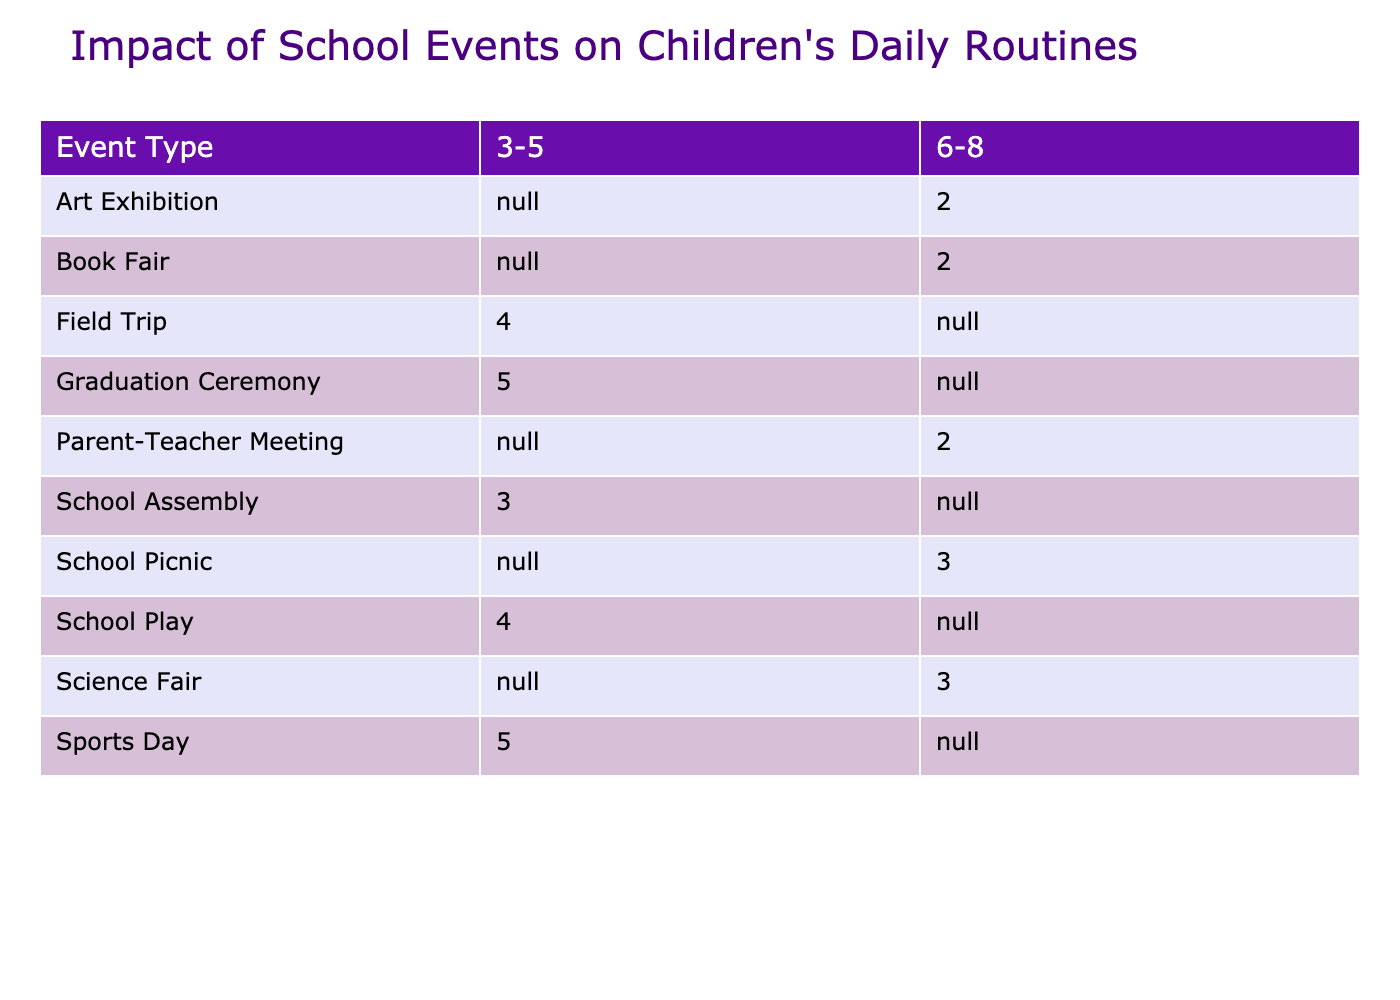What is the disruption level of Sports Day for the 3-5 age group? From the table, under the event "Sports Day" and in the column for the 3-5 age group, the disruption level is listed as 5.
Answer: 5 Which event has the highest average disruption level for children aged 3-5? By looking at the disruption levels for the 3-5 age group: School Play (4), Sports Day (5), School Assembly (3), Graduation Ceremony (5), and Field Trip (4), the highest average disruption levels are shared by Sports Day and Graduation Ceremony, both at 5.
Answer: Sports Day and Graduation Ceremony What is the average disruption level for the 6-8 age group? To find the average disruption level for the 6-8 age group, we will take the disruption levels: Picnic (3), Parent-Teacher Meeting (2), Art Exhibition (2), Science Fair (3), and Book Fair (2). Summing these gives us 3 + 2 + 2 + 3 + 2 = 12. There are 5 events, so the average is 12 divided by 5, which equals 2.4.
Answer: 2.4 Is there any event where the parent's annoyance level is at least 4 for the 3-5 age group? Examining the parent's annoyance levels for the 3-5 age group: School Play (5), Sports Day (5), School Assembly (2), Graduation Ceremony (5), and Field Trip (4), all of these events except for School Assembly have an annoyance level of at least 4, which means there are multiple events that meet this criterion.
Answer: Yes What is the difference in disruption levels between the Field Trip and the Book Fair for the 6-8 age group? According to the table, the disruption level for the Field Trip does not apply to the 6-8 age group. However, for the Book Fair, the disruption level is 2. Therefore, since the Field Trip disruption level cannot be determined, the difference calculation isn't applicable here.
Answer: Not applicable 